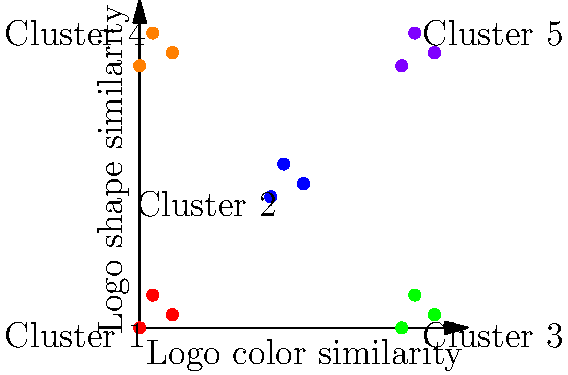In an effort to promote unity among diverse sports teams, you're analyzing logo designs using machine learning clustering techniques. The graph shows the results of clustering 15 team logos based on their color and shape similarities. How many distinct clusters are formed, and what might this suggest about the potential for creating unified branding across these teams? To answer this question, we need to analyze the graph step-by-step:

1. Observe the axes:
   - X-axis represents "Logo color similarity"
   - Y-axis represents "Logo shape similarity"

2. Identify the clusters:
   - Look for groups of points with the same color and close proximity
   - Count the number of distinct groups

3. Analyze the clusters:
   - Cluster 1: Bottom-left (red)
   - Cluster 2: Center (blue)
   - Cluster 3: Bottom-right (green)
   - Cluster 4: Top-left (orange)
   - Cluster 5: Top-right (purple)

4. Count the clusters:
   - There are 5 distinct clusters

5. Interpret the results:
   - Each cluster represents a group of teams with similar logo designs
   - The 5 clusters suggest diversity in current logo designs
   - Teams within each cluster have potential for unified branding
   - Cross-cluster unity may require more significant design changes

6. Consider the implications for promoting unity:
   - Teams within the same cluster could easily adopt similar branding
   - Creating unity across all teams might require finding common elements or creating a new design that incorporates aspects from all clusters
Answer: 5 clusters; suggests potential for unified branding within clusters, but challenges for overall unity due to diverse designs. 